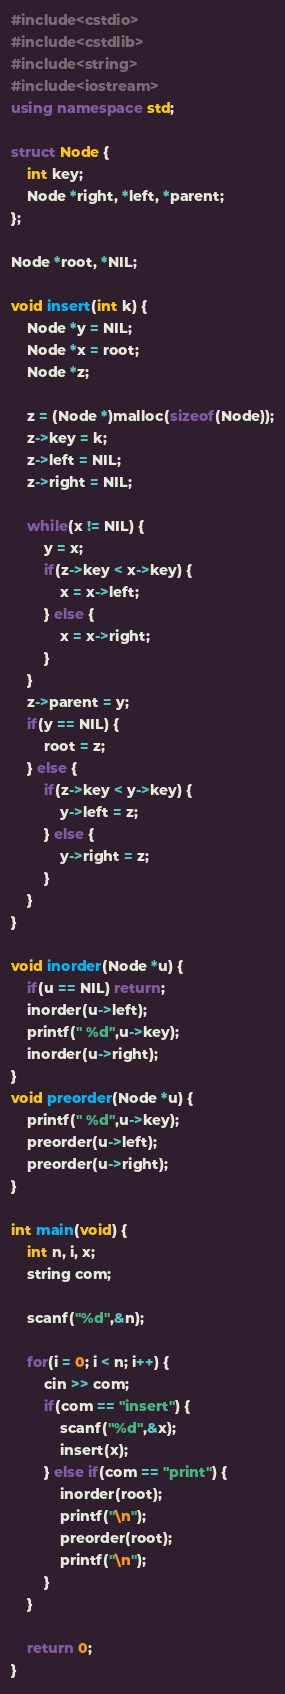Convert code to text. <code><loc_0><loc_0><loc_500><loc_500><_C++_>#include<cstdio>
#include<cstdlib>
#include<string>
#include<iostream>
using namespace std;

struct Node {
    int key;
    Node *right, *left, *parent;
};

Node *root, *NIL;

void insert(int k) {
    Node *y = NIL;
    Node *x = root;
    Node *z;

    z = (Node *)malloc(sizeof(Node));
    z->key = k;
    z->left = NIL;
    z->right = NIL;

    while(x != NIL) {
        y = x;
        if(z->key < x->key) {
            x = x->left;
        } else {
            x = x->right;
        }
    }
    z->parent = y;
    if(y == NIL) {
        root = z;
    } else {
        if(z->key < y->key) {
            y->left = z;
        } else {
            y->right = z;
        }
    }
}

void inorder(Node *u) {
    if(u == NIL) return;
    inorder(u->left);
    printf(" %d",u->key);
    inorder(u->right);
}
void preorder(Node *u) {
    printf(" %d",u->key);
    preorder(u->left);
    preorder(u->right);
}

int main(void) {
    int n, i, x;
    string com;

    scanf("%d",&n);

    for(i = 0; i < n; i++) {
        cin >> com;
        if(com == "insert") {
            scanf("%d",&x);
            insert(x);
        } else if(com == "print") {
            inorder(root);
            printf("\n");
            preorder(root);
            printf("\n");
        }
    }

    return 0;
}
</code> 